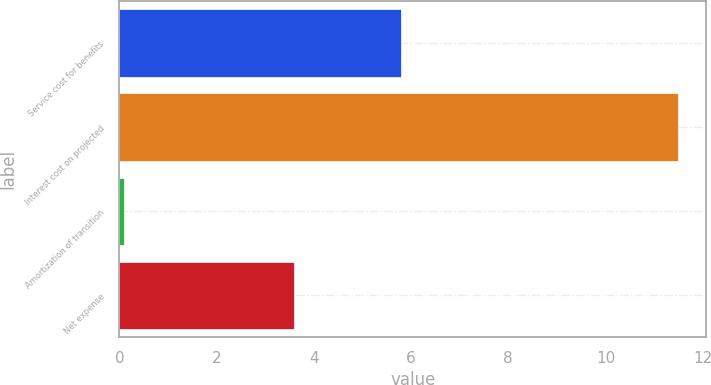Convert chart. <chart><loc_0><loc_0><loc_500><loc_500><bar_chart><fcel>Service cost for benefits<fcel>Interest cost on projected<fcel>Amortization of transition<fcel>Net expense<nl><fcel>5.8<fcel>11.5<fcel>0.1<fcel>3.6<nl></chart> 